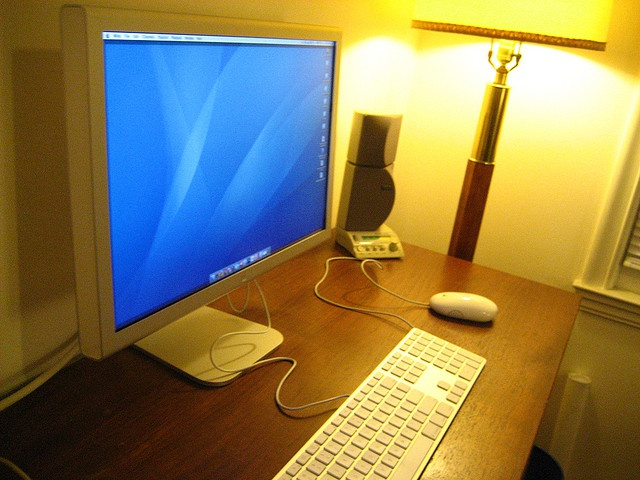Describe the objects in this image and their specific colors. I can see tv in olive, lightblue, and blue tones, keyboard in olive, khaki, tan, and lightyellow tones, and mouse in olive, khaki, and tan tones in this image. 